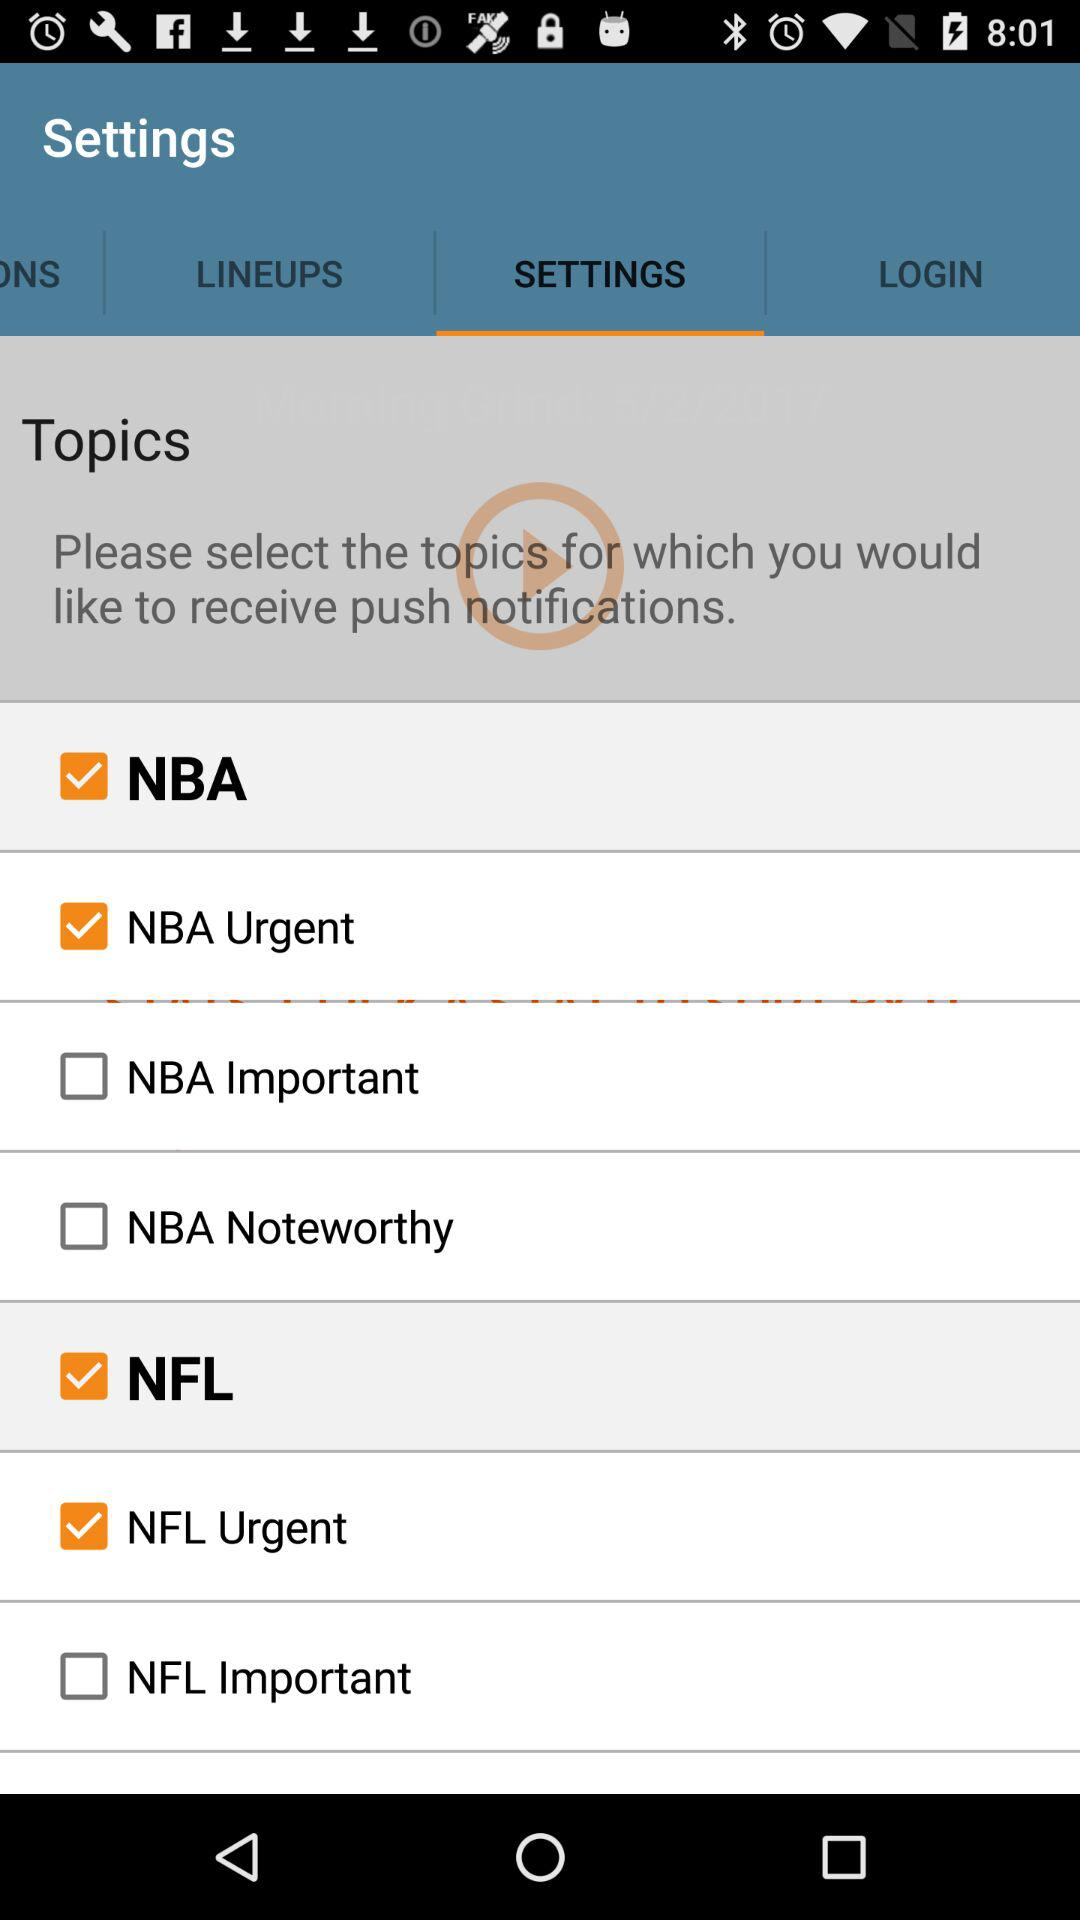How many topics are related to NBA?
Answer the question using a single word or phrase. 3 